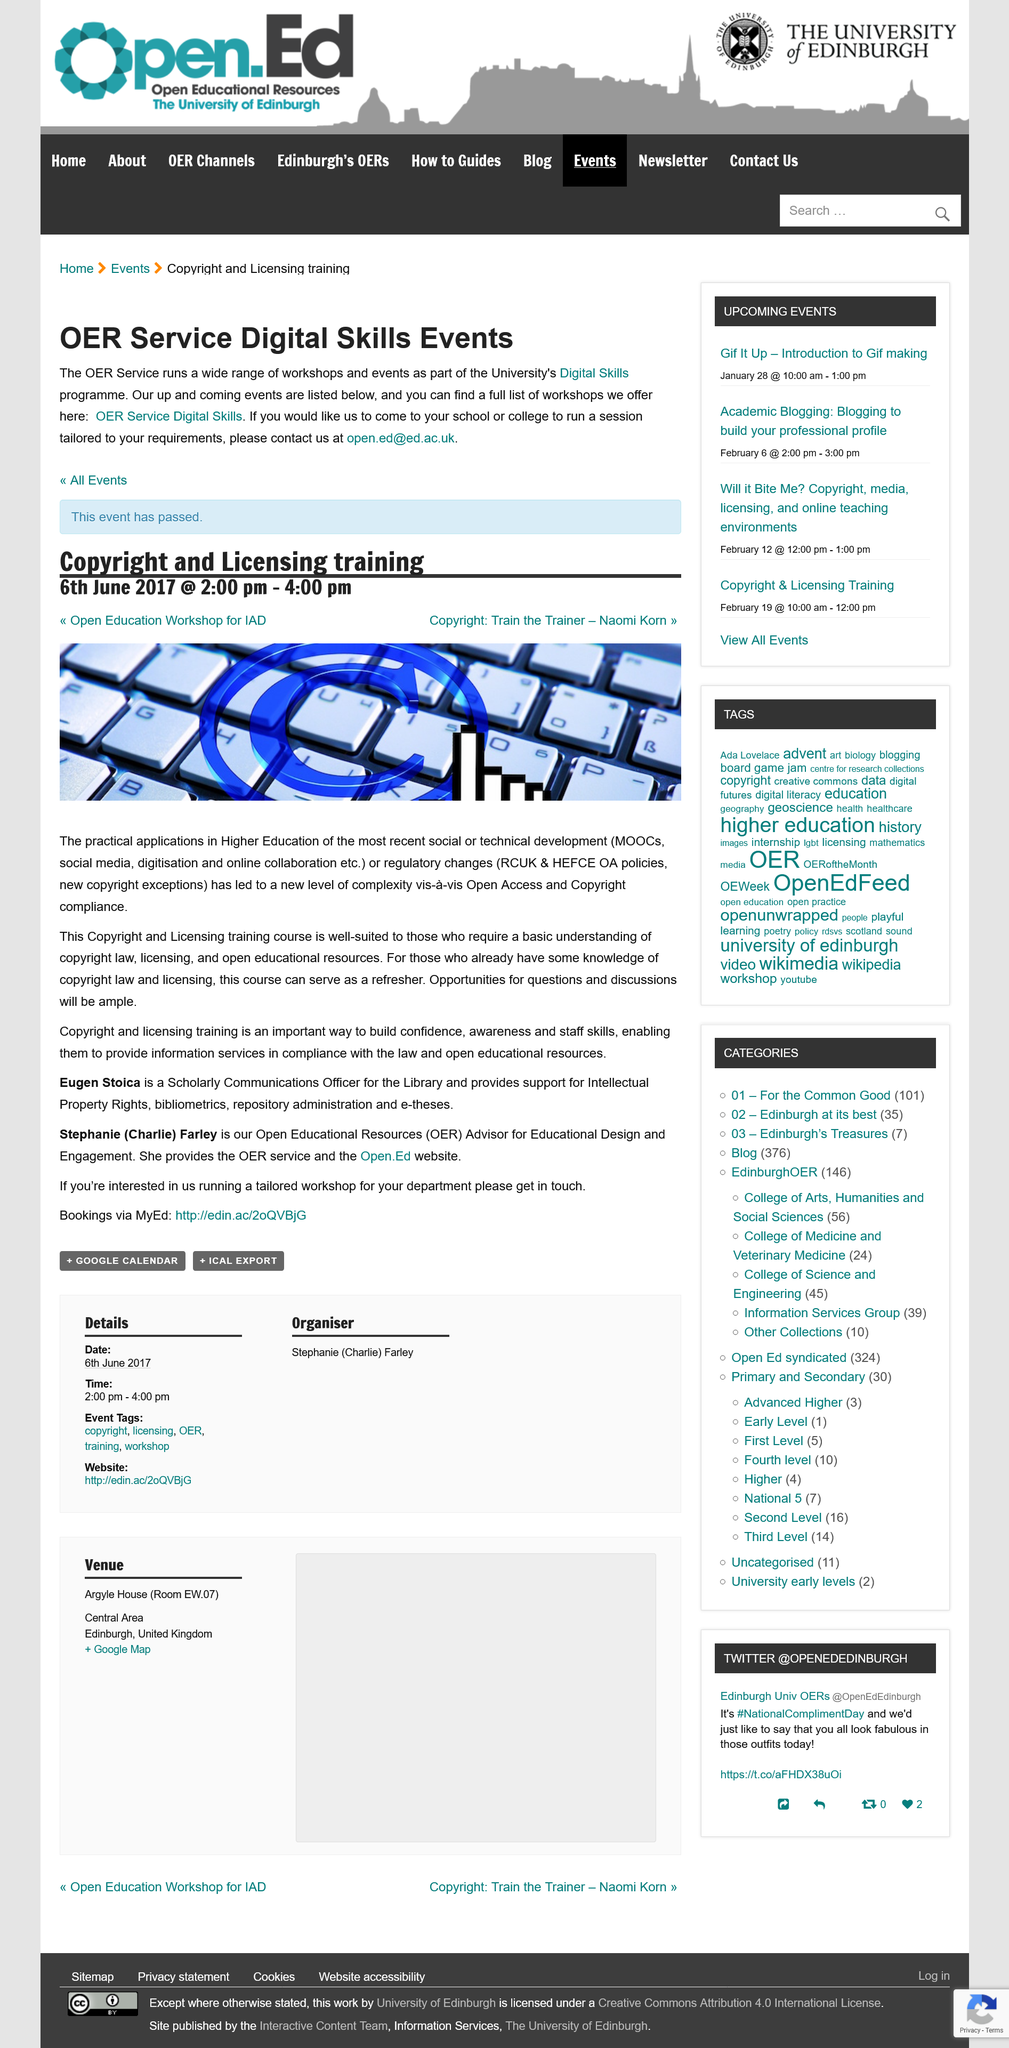Specify some key components in this picture. Eugen Stocia is a Scholarly Communications Officer for the Library. The Copyright and Licensing Training is scheduled to take place from 2:00pm to 4:00pm. The bookings process takes place through the website specified on MyEd and not through any other means. 